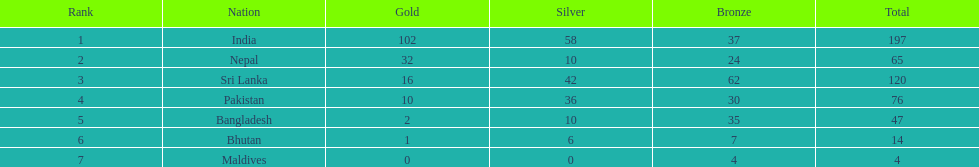What are all the countries displayed in the table? India, Nepal, Sri Lanka, Pakistan, Bangladesh, Bhutan, Maldives. Which of these isn't india? Nepal, Sri Lanka, Pakistan, Bangladesh, Bhutan, Maldives. Out of these, which is the foremost? Nepal. 